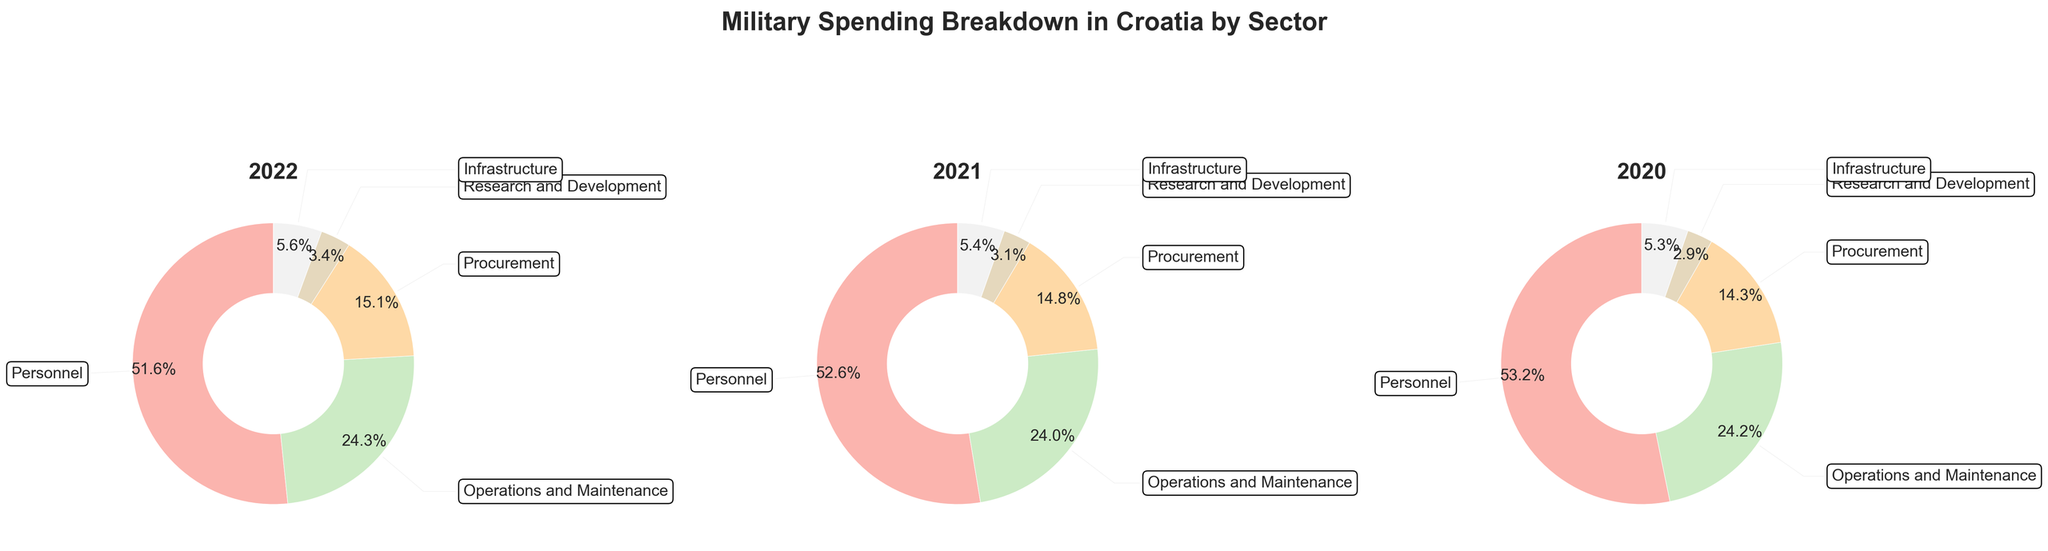What is the title of the figure? The title is usually displayed at the top of the figure in larger, bold font. Here it says "Military Spending Breakdown in Croatia by Sector".
Answer: Military Spending Breakdown in Croatia by Sector Which year has the highest spending on personnel? By looking at the pie charts for each year, you can see that the amount spent on personnel is largest in the chart for 2022.
Answer: 2022 Compare the spending on Operations and Maintenance between 2021 and 2022. Which year had higher spending and by how much? Find the slices labeled "Operations and Maintenance" in the 2021 and 2022 pie charts. 2022 has 1480 million HRK and 2021 has 1380 million HRK. The difference is 1480 - 1380.
Answer: 2022, by 100 million HRK Which category had the smallest spending in 2020? Look at the smallest wedge of the pie chart for 2020. It's labeled "Research and Development".
Answer: Research and Development What percentage of the 2021 spending was allocated to Procurement? The "Procurement" wedge in the 2021 pie chart shows the percentage directly on it as 16.6%.
Answer: 16.6% How did the percentage allocated to Infrastructure change from 2020 to 2022? Locate the percentages for "Infrastructure" in the 2020 and 2022 pie charts. 2020 has 5.1% and 2022 has 5.6%. The change is calculated as 5.6% - 5.1%.
Answer: Increased by 0.5% List the spending categories in descending order for 2022. Look at the wedges and their labeled percentages for the 2022 pie chart. Largest to smallest: Personnel, Operations and Maintenance, Procurement, Infrastructure, Research and Development.
Answer: Personnel, Operations and Maintenance, Procurement, Infrastructure, Research and Development What is the combined total spending on Research and Development over the three years? Sum the spending values for Research and Development from 2020 (160), 2021 (180), and 2022 (210). The total is 160 + 180 + 210.
Answer: 550 million HRK Was there any category with a decreasing trend in spending over the three years? Examine each category across the three years. Research and Development had increasing spending each year, and so did the other categories.
Answer: No Which year had the total lowest military spending? Although total spending isn't directly shown, summing up the spending across categories for each year reveals that 2020 had the lowest total
Answer: 2020 